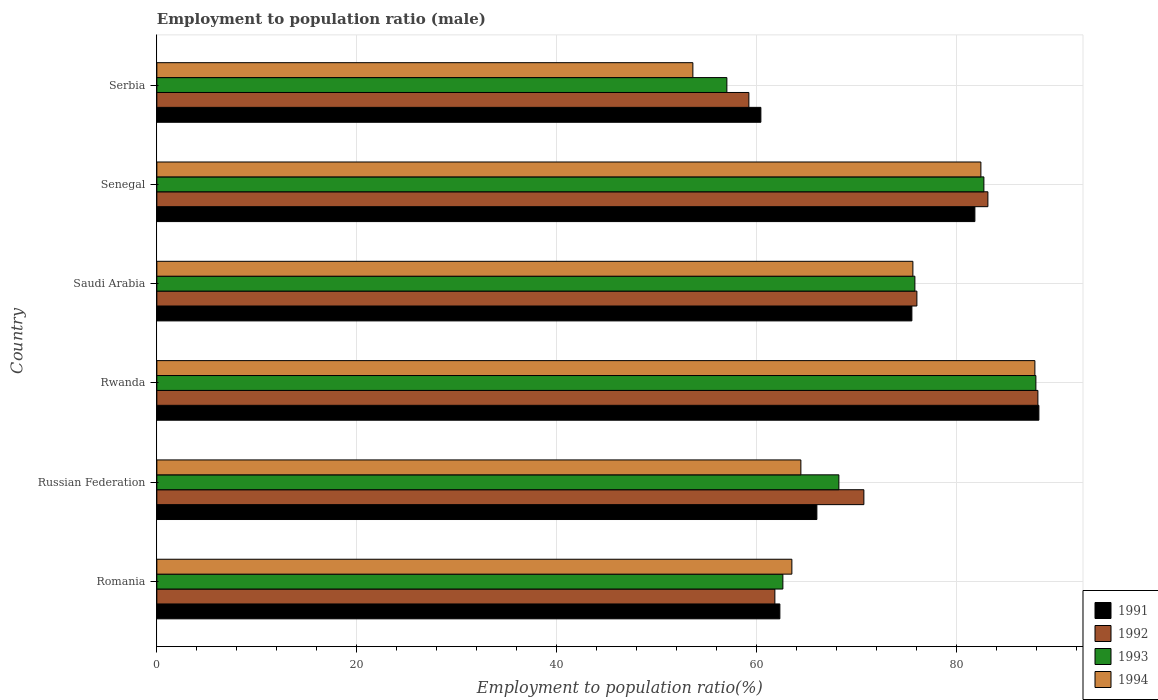How many different coloured bars are there?
Provide a succinct answer. 4. Are the number of bars per tick equal to the number of legend labels?
Keep it short and to the point. Yes. Are the number of bars on each tick of the Y-axis equal?
Offer a very short reply. Yes. How many bars are there on the 5th tick from the top?
Provide a succinct answer. 4. How many bars are there on the 2nd tick from the bottom?
Your answer should be compact. 4. What is the label of the 1st group of bars from the top?
Give a very brief answer. Serbia. In how many cases, is the number of bars for a given country not equal to the number of legend labels?
Your answer should be very brief. 0. What is the employment to population ratio in 1992 in Romania?
Offer a very short reply. 61.8. Across all countries, what is the maximum employment to population ratio in 1994?
Ensure brevity in your answer.  87.8. Across all countries, what is the minimum employment to population ratio in 1991?
Make the answer very short. 60.4. In which country was the employment to population ratio in 1994 maximum?
Your answer should be very brief. Rwanda. In which country was the employment to population ratio in 1991 minimum?
Offer a terse response. Serbia. What is the total employment to population ratio in 1993 in the graph?
Give a very brief answer. 434.2. What is the difference between the employment to population ratio in 1994 in Romania and that in Serbia?
Make the answer very short. 9.9. What is the difference between the employment to population ratio in 1992 in Serbia and the employment to population ratio in 1991 in Russian Federation?
Ensure brevity in your answer.  -6.8. What is the average employment to population ratio in 1993 per country?
Offer a very short reply. 72.37. What is the difference between the employment to population ratio in 1992 and employment to population ratio in 1993 in Rwanda?
Keep it short and to the point. 0.2. In how many countries, is the employment to population ratio in 1992 greater than 56 %?
Keep it short and to the point. 6. What is the ratio of the employment to population ratio in 1994 in Rwanda to that in Serbia?
Offer a terse response. 1.64. Is the employment to population ratio in 1993 in Rwanda less than that in Serbia?
Your answer should be compact. No. What is the difference between the highest and the second highest employment to population ratio in 1994?
Give a very brief answer. 5.4. What is the difference between the highest and the lowest employment to population ratio in 1994?
Provide a succinct answer. 34.2. In how many countries, is the employment to population ratio in 1994 greater than the average employment to population ratio in 1994 taken over all countries?
Your answer should be compact. 3. Is the sum of the employment to population ratio in 1992 in Senegal and Serbia greater than the maximum employment to population ratio in 1994 across all countries?
Your answer should be very brief. Yes. Is it the case that in every country, the sum of the employment to population ratio in 1992 and employment to population ratio in 1993 is greater than the sum of employment to population ratio in 1991 and employment to population ratio in 1994?
Ensure brevity in your answer.  No. What does the 2nd bar from the top in Romania represents?
Offer a terse response. 1993. Are all the bars in the graph horizontal?
Offer a very short reply. Yes. What is the difference between two consecutive major ticks on the X-axis?
Your response must be concise. 20. Are the values on the major ticks of X-axis written in scientific E-notation?
Your answer should be very brief. No. Does the graph contain any zero values?
Your response must be concise. No. How many legend labels are there?
Offer a terse response. 4. How are the legend labels stacked?
Offer a very short reply. Vertical. What is the title of the graph?
Give a very brief answer. Employment to population ratio (male). What is the label or title of the X-axis?
Give a very brief answer. Employment to population ratio(%). What is the label or title of the Y-axis?
Your response must be concise. Country. What is the Employment to population ratio(%) in 1991 in Romania?
Make the answer very short. 62.3. What is the Employment to population ratio(%) of 1992 in Romania?
Your answer should be very brief. 61.8. What is the Employment to population ratio(%) of 1993 in Romania?
Keep it short and to the point. 62.6. What is the Employment to population ratio(%) in 1994 in Romania?
Offer a very short reply. 63.5. What is the Employment to population ratio(%) in 1992 in Russian Federation?
Your answer should be compact. 70.7. What is the Employment to population ratio(%) in 1993 in Russian Federation?
Keep it short and to the point. 68.2. What is the Employment to population ratio(%) of 1994 in Russian Federation?
Keep it short and to the point. 64.4. What is the Employment to population ratio(%) in 1991 in Rwanda?
Your answer should be compact. 88.2. What is the Employment to population ratio(%) of 1992 in Rwanda?
Give a very brief answer. 88.1. What is the Employment to population ratio(%) in 1993 in Rwanda?
Provide a succinct answer. 87.9. What is the Employment to population ratio(%) of 1994 in Rwanda?
Your answer should be compact. 87.8. What is the Employment to population ratio(%) of 1991 in Saudi Arabia?
Make the answer very short. 75.5. What is the Employment to population ratio(%) of 1993 in Saudi Arabia?
Your answer should be very brief. 75.8. What is the Employment to population ratio(%) in 1994 in Saudi Arabia?
Your response must be concise. 75.6. What is the Employment to population ratio(%) in 1991 in Senegal?
Provide a succinct answer. 81.8. What is the Employment to population ratio(%) in 1992 in Senegal?
Make the answer very short. 83.1. What is the Employment to population ratio(%) in 1993 in Senegal?
Ensure brevity in your answer.  82.7. What is the Employment to population ratio(%) of 1994 in Senegal?
Give a very brief answer. 82.4. What is the Employment to population ratio(%) of 1991 in Serbia?
Your response must be concise. 60.4. What is the Employment to population ratio(%) of 1992 in Serbia?
Provide a short and direct response. 59.2. What is the Employment to population ratio(%) of 1993 in Serbia?
Your answer should be compact. 57. What is the Employment to population ratio(%) of 1994 in Serbia?
Your response must be concise. 53.6. Across all countries, what is the maximum Employment to population ratio(%) in 1991?
Your response must be concise. 88.2. Across all countries, what is the maximum Employment to population ratio(%) in 1992?
Offer a very short reply. 88.1. Across all countries, what is the maximum Employment to population ratio(%) of 1993?
Provide a short and direct response. 87.9. Across all countries, what is the maximum Employment to population ratio(%) in 1994?
Keep it short and to the point. 87.8. Across all countries, what is the minimum Employment to population ratio(%) of 1991?
Offer a very short reply. 60.4. Across all countries, what is the minimum Employment to population ratio(%) in 1992?
Your response must be concise. 59.2. Across all countries, what is the minimum Employment to population ratio(%) in 1994?
Offer a terse response. 53.6. What is the total Employment to population ratio(%) of 1991 in the graph?
Make the answer very short. 434.2. What is the total Employment to population ratio(%) of 1992 in the graph?
Your answer should be compact. 438.9. What is the total Employment to population ratio(%) of 1993 in the graph?
Offer a terse response. 434.2. What is the total Employment to population ratio(%) of 1994 in the graph?
Your answer should be very brief. 427.3. What is the difference between the Employment to population ratio(%) in 1992 in Romania and that in Russian Federation?
Offer a very short reply. -8.9. What is the difference between the Employment to population ratio(%) of 1993 in Romania and that in Russian Federation?
Keep it short and to the point. -5.6. What is the difference between the Employment to population ratio(%) of 1994 in Romania and that in Russian Federation?
Provide a succinct answer. -0.9. What is the difference between the Employment to population ratio(%) of 1991 in Romania and that in Rwanda?
Give a very brief answer. -25.9. What is the difference between the Employment to population ratio(%) in 1992 in Romania and that in Rwanda?
Ensure brevity in your answer.  -26.3. What is the difference between the Employment to population ratio(%) of 1993 in Romania and that in Rwanda?
Give a very brief answer. -25.3. What is the difference between the Employment to population ratio(%) in 1994 in Romania and that in Rwanda?
Give a very brief answer. -24.3. What is the difference between the Employment to population ratio(%) in 1991 in Romania and that in Saudi Arabia?
Your answer should be compact. -13.2. What is the difference between the Employment to population ratio(%) in 1993 in Romania and that in Saudi Arabia?
Your answer should be very brief. -13.2. What is the difference between the Employment to population ratio(%) of 1994 in Romania and that in Saudi Arabia?
Keep it short and to the point. -12.1. What is the difference between the Employment to population ratio(%) in 1991 in Romania and that in Senegal?
Your answer should be very brief. -19.5. What is the difference between the Employment to population ratio(%) of 1992 in Romania and that in Senegal?
Provide a short and direct response. -21.3. What is the difference between the Employment to population ratio(%) in 1993 in Romania and that in Senegal?
Offer a very short reply. -20.1. What is the difference between the Employment to population ratio(%) of 1994 in Romania and that in Senegal?
Offer a very short reply. -18.9. What is the difference between the Employment to population ratio(%) of 1993 in Romania and that in Serbia?
Keep it short and to the point. 5.6. What is the difference between the Employment to population ratio(%) in 1994 in Romania and that in Serbia?
Provide a short and direct response. 9.9. What is the difference between the Employment to population ratio(%) in 1991 in Russian Federation and that in Rwanda?
Keep it short and to the point. -22.2. What is the difference between the Employment to population ratio(%) in 1992 in Russian Federation and that in Rwanda?
Your response must be concise. -17.4. What is the difference between the Employment to population ratio(%) in 1993 in Russian Federation and that in Rwanda?
Your answer should be very brief. -19.7. What is the difference between the Employment to population ratio(%) of 1994 in Russian Federation and that in Rwanda?
Keep it short and to the point. -23.4. What is the difference between the Employment to population ratio(%) in 1991 in Russian Federation and that in Saudi Arabia?
Provide a short and direct response. -9.5. What is the difference between the Employment to population ratio(%) in 1992 in Russian Federation and that in Saudi Arabia?
Ensure brevity in your answer.  -5.3. What is the difference between the Employment to population ratio(%) of 1991 in Russian Federation and that in Senegal?
Your answer should be compact. -15.8. What is the difference between the Employment to population ratio(%) of 1994 in Russian Federation and that in Senegal?
Give a very brief answer. -18. What is the difference between the Employment to population ratio(%) of 1992 in Russian Federation and that in Serbia?
Ensure brevity in your answer.  11.5. What is the difference between the Employment to population ratio(%) in 1994 in Russian Federation and that in Serbia?
Keep it short and to the point. 10.8. What is the difference between the Employment to population ratio(%) in 1991 in Rwanda and that in Saudi Arabia?
Offer a terse response. 12.7. What is the difference between the Employment to population ratio(%) in 1992 in Rwanda and that in Saudi Arabia?
Your answer should be compact. 12.1. What is the difference between the Employment to population ratio(%) of 1993 in Rwanda and that in Saudi Arabia?
Keep it short and to the point. 12.1. What is the difference between the Employment to population ratio(%) in 1994 in Rwanda and that in Saudi Arabia?
Make the answer very short. 12.2. What is the difference between the Employment to population ratio(%) of 1992 in Rwanda and that in Senegal?
Your answer should be very brief. 5. What is the difference between the Employment to population ratio(%) of 1993 in Rwanda and that in Senegal?
Give a very brief answer. 5.2. What is the difference between the Employment to population ratio(%) in 1994 in Rwanda and that in Senegal?
Ensure brevity in your answer.  5.4. What is the difference between the Employment to population ratio(%) in 1991 in Rwanda and that in Serbia?
Ensure brevity in your answer.  27.8. What is the difference between the Employment to population ratio(%) in 1992 in Rwanda and that in Serbia?
Give a very brief answer. 28.9. What is the difference between the Employment to population ratio(%) in 1993 in Rwanda and that in Serbia?
Give a very brief answer. 30.9. What is the difference between the Employment to population ratio(%) of 1994 in Rwanda and that in Serbia?
Ensure brevity in your answer.  34.2. What is the difference between the Employment to population ratio(%) of 1992 in Saudi Arabia and that in Senegal?
Offer a terse response. -7.1. What is the difference between the Employment to population ratio(%) in 1992 in Saudi Arabia and that in Serbia?
Offer a terse response. 16.8. What is the difference between the Employment to population ratio(%) of 1993 in Saudi Arabia and that in Serbia?
Make the answer very short. 18.8. What is the difference between the Employment to population ratio(%) in 1991 in Senegal and that in Serbia?
Make the answer very short. 21.4. What is the difference between the Employment to population ratio(%) in 1992 in Senegal and that in Serbia?
Your answer should be compact. 23.9. What is the difference between the Employment to population ratio(%) in 1993 in Senegal and that in Serbia?
Offer a terse response. 25.7. What is the difference between the Employment to population ratio(%) of 1994 in Senegal and that in Serbia?
Provide a succinct answer. 28.8. What is the difference between the Employment to population ratio(%) of 1991 in Romania and the Employment to population ratio(%) of 1992 in Rwanda?
Give a very brief answer. -25.8. What is the difference between the Employment to population ratio(%) of 1991 in Romania and the Employment to population ratio(%) of 1993 in Rwanda?
Your response must be concise. -25.6. What is the difference between the Employment to population ratio(%) of 1991 in Romania and the Employment to population ratio(%) of 1994 in Rwanda?
Ensure brevity in your answer.  -25.5. What is the difference between the Employment to population ratio(%) in 1992 in Romania and the Employment to population ratio(%) in 1993 in Rwanda?
Give a very brief answer. -26.1. What is the difference between the Employment to population ratio(%) in 1992 in Romania and the Employment to population ratio(%) in 1994 in Rwanda?
Give a very brief answer. -26. What is the difference between the Employment to population ratio(%) of 1993 in Romania and the Employment to population ratio(%) of 1994 in Rwanda?
Your answer should be very brief. -25.2. What is the difference between the Employment to population ratio(%) in 1991 in Romania and the Employment to population ratio(%) in 1992 in Saudi Arabia?
Make the answer very short. -13.7. What is the difference between the Employment to population ratio(%) of 1991 in Romania and the Employment to population ratio(%) of 1993 in Saudi Arabia?
Offer a very short reply. -13.5. What is the difference between the Employment to population ratio(%) in 1992 in Romania and the Employment to population ratio(%) in 1994 in Saudi Arabia?
Give a very brief answer. -13.8. What is the difference between the Employment to population ratio(%) in 1991 in Romania and the Employment to population ratio(%) in 1992 in Senegal?
Your response must be concise. -20.8. What is the difference between the Employment to population ratio(%) in 1991 in Romania and the Employment to population ratio(%) in 1993 in Senegal?
Ensure brevity in your answer.  -20.4. What is the difference between the Employment to population ratio(%) of 1991 in Romania and the Employment to population ratio(%) of 1994 in Senegal?
Make the answer very short. -20.1. What is the difference between the Employment to population ratio(%) in 1992 in Romania and the Employment to population ratio(%) in 1993 in Senegal?
Your answer should be compact. -20.9. What is the difference between the Employment to population ratio(%) of 1992 in Romania and the Employment to population ratio(%) of 1994 in Senegal?
Ensure brevity in your answer.  -20.6. What is the difference between the Employment to population ratio(%) of 1993 in Romania and the Employment to population ratio(%) of 1994 in Senegal?
Your response must be concise. -19.8. What is the difference between the Employment to population ratio(%) of 1991 in Romania and the Employment to population ratio(%) of 1993 in Serbia?
Offer a very short reply. 5.3. What is the difference between the Employment to population ratio(%) of 1993 in Romania and the Employment to population ratio(%) of 1994 in Serbia?
Your response must be concise. 9. What is the difference between the Employment to population ratio(%) in 1991 in Russian Federation and the Employment to population ratio(%) in 1992 in Rwanda?
Ensure brevity in your answer.  -22.1. What is the difference between the Employment to population ratio(%) in 1991 in Russian Federation and the Employment to population ratio(%) in 1993 in Rwanda?
Make the answer very short. -21.9. What is the difference between the Employment to population ratio(%) in 1991 in Russian Federation and the Employment to population ratio(%) in 1994 in Rwanda?
Give a very brief answer. -21.8. What is the difference between the Employment to population ratio(%) in 1992 in Russian Federation and the Employment to population ratio(%) in 1993 in Rwanda?
Your answer should be very brief. -17.2. What is the difference between the Employment to population ratio(%) in 1992 in Russian Federation and the Employment to population ratio(%) in 1994 in Rwanda?
Provide a short and direct response. -17.1. What is the difference between the Employment to population ratio(%) in 1993 in Russian Federation and the Employment to population ratio(%) in 1994 in Rwanda?
Your answer should be compact. -19.6. What is the difference between the Employment to population ratio(%) of 1991 in Russian Federation and the Employment to population ratio(%) of 1992 in Saudi Arabia?
Your answer should be very brief. -10. What is the difference between the Employment to population ratio(%) of 1991 in Russian Federation and the Employment to population ratio(%) of 1994 in Saudi Arabia?
Keep it short and to the point. -9.6. What is the difference between the Employment to population ratio(%) in 1992 in Russian Federation and the Employment to population ratio(%) in 1993 in Saudi Arabia?
Your response must be concise. -5.1. What is the difference between the Employment to population ratio(%) of 1992 in Russian Federation and the Employment to population ratio(%) of 1994 in Saudi Arabia?
Your response must be concise. -4.9. What is the difference between the Employment to population ratio(%) of 1991 in Russian Federation and the Employment to population ratio(%) of 1992 in Senegal?
Provide a short and direct response. -17.1. What is the difference between the Employment to population ratio(%) of 1991 in Russian Federation and the Employment to population ratio(%) of 1993 in Senegal?
Keep it short and to the point. -16.7. What is the difference between the Employment to population ratio(%) of 1991 in Russian Federation and the Employment to population ratio(%) of 1994 in Senegal?
Give a very brief answer. -16.4. What is the difference between the Employment to population ratio(%) of 1991 in Russian Federation and the Employment to population ratio(%) of 1994 in Serbia?
Provide a short and direct response. 12.4. What is the difference between the Employment to population ratio(%) of 1992 in Russian Federation and the Employment to population ratio(%) of 1994 in Serbia?
Your answer should be very brief. 17.1. What is the difference between the Employment to population ratio(%) of 1991 in Rwanda and the Employment to population ratio(%) of 1994 in Saudi Arabia?
Provide a short and direct response. 12.6. What is the difference between the Employment to population ratio(%) of 1992 in Rwanda and the Employment to population ratio(%) of 1993 in Saudi Arabia?
Provide a short and direct response. 12.3. What is the difference between the Employment to population ratio(%) in 1992 in Rwanda and the Employment to population ratio(%) in 1994 in Saudi Arabia?
Provide a succinct answer. 12.5. What is the difference between the Employment to population ratio(%) in 1991 in Rwanda and the Employment to population ratio(%) in 1993 in Senegal?
Provide a succinct answer. 5.5. What is the difference between the Employment to population ratio(%) of 1991 in Rwanda and the Employment to population ratio(%) of 1994 in Senegal?
Give a very brief answer. 5.8. What is the difference between the Employment to population ratio(%) in 1992 in Rwanda and the Employment to population ratio(%) in 1993 in Senegal?
Keep it short and to the point. 5.4. What is the difference between the Employment to population ratio(%) of 1992 in Rwanda and the Employment to population ratio(%) of 1994 in Senegal?
Your response must be concise. 5.7. What is the difference between the Employment to population ratio(%) in 1991 in Rwanda and the Employment to population ratio(%) in 1992 in Serbia?
Keep it short and to the point. 29. What is the difference between the Employment to population ratio(%) in 1991 in Rwanda and the Employment to population ratio(%) in 1993 in Serbia?
Your response must be concise. 31.2. What is the difference between the Employment to population ratio(%) of 1991 in Rwanda and the Employment to population ratio(%) of 1994 in Serbia?
Ensure brevity in your answer.  34.6. What is the difference between the Employment to population ratio(%) in 1992 in Rwanda and the Employment to population ratio(%) in 1993 in Serbia?
Give a very brief answer. 31.1. What is the difference between the Employment to population ratio(%) in 1992 in Rwanda and the Employment to population ratio(%) in 1994 in Serbia?
Make the answer very short. 34.5. What is the difference between the Employment to population ratio(%) of 1993 in Rwanda and the Employment to population ratio(%) of 1994 in Serbia?
Make the answer very short. 34.3. What is the difference between the Employment to population ratio(%) of 1991 in Saudi Arabia and the Employment to population ratio(%) of 1993 in Senegal?
Provide a short and direct response. -7.2. What is the difference between the Employment to population ratio(%) of 1991 in Saudi Arabia and the Employment to population ratio(%) of 1994 in Senegal?
Offer a terse response. -6.9. What is the difference between the Employment to population ratio(%) in 1992 in Saudi Arabia and the Employment to population ratio(%) in 1993 in Senegal?
Keep it short and to the point. -6.7. What is the difference between the Employment to population ratio(%) of 1992 in Saudi Arabia and the Employment to population ratio(%) of 1994 in Senegal?
Ensure brevity in your answer.  -6.4. What is the difference between the Employment to population ratio(%) of 1993 in Saudi Arabia and the Employment to population ratio(%) of 1994 in Senegal?
Keep it short and to the point. -6.6. What is the difference between the Employment to population ratio(%) in 1991 in Saudi Arabia and the Employment to population ratio(%) in 1992 in Serbia?
Give a very brief answer. 16.3. What is the difference between the Employment to population ratio(%) in 1991 in Saudi Arabia and the Employment to population ratio(%) in 1993 in Serbia?
Keep it short and to the point. 18.5. What is the difference between the Employment to population ratio(%) in 1991 in Saudi Arabia and the Employment to population ratio(%) in 1994 in Serbia?
Ensure brevity in your answer.  21.9. What is the difference between the Employment to population ratio(%) of 1992 in Saudi Arabia and the Employment to population ratio(%) of 1994 in Serbia?
Make the answer very short. 22.4. What is the difference between the Employment to population ratio(%) in 1993 in Saudi Arabia and the Employment to population ratio(%) in 1994 in Serbia?
Offer a terse response. 22.2. What is the difference between the Employment to population ratio(%) in 1991 in Senegal and the Employment to population ratio(%) in 1992 in Serbia?
Your answer should be compact. 22.6. What is the difference between the Employment to population ratio(%) in 1991 in Senegal and the Employment to population ratio(%) in 1993 in Serbia?
Keep it short and to the point. 24.8. What is the difference between the Employment to population ratio(%) in 1991 in Senegal and the Employment to population ratio(%) in 1994 in Serbia?
Your response must be concise. 28.2. What is the difference between the Employment to population ratio(%) of 1992 in Senegal and the Employment to population ratio(%) of 1993 in Serbia?
Make the answer very short. 26.1. What is the difference between the Employment to population ratio(%) of 1992 in Senegal and the Employment to population ratio(%) of 1994 in Serbia?
Your answer should be very brief. 29.5. What is the difference between the Employment to population ratio(%) of 1993 in Senegal and the Employment to population ratio(%) of 1994 in Serbia?
Offer a very short reply. 29.1. What is the average Employment to population ratio(%) in 1991 per country?
Offer a very short reply. 72.37. What is the average Employment to population ratio(%) in 1992 per country?
Provide a succinct answer. 73.15. What is the average Employment to population ratio(%) in 1993 per country?
Make the answer very short. 72.37. What is the average Employment to population ratio(%) of 1994 per country?
Provide a short and direct response. 71.22. What is the difference between the Employment to population ratio(%) in 1991 and Employment to population ratio(%) in 1993 in Romania?
Give a very brief answer. -0.3. What is the difference between the Employment to population ratio(%) in 1992 and Employment to population ratio(%) in 1994 in Romania?
Your response must be concise. -1.7. What is the difference between the Employment to population ratio(%) in 1991 and Employment to population ratio(%) in 1992 in Russian Federation?
Offer a very short reply. -4.7. What is the difference between the Employment to population ratio(%) of 1991 and Employment to population ratio(%) of 1993 in Russian Federation?
Your answer should be compact. -2.2. What is the difference between the Employment to population ratio(%) of 1991 and Employment to population ratio(%) of 1994 in Russian Federation?
Offer a very short reply. 1.6. What is the difference between the Employment to population ratio(%) of 1991 and Employment to population ratio(%) of 1993 in Rwanda?
Make the answer very short. 0.3. What is the difference between the Employment to population ratio(%) in 1992 and Employment to population ratio(%) in 1993 in Rwanda?
Make the answer very short. 0.2. What is the difference between the Employment to population ratio(%) in 1993 and Employment to population ratio(%) in 1994 in Rwanda?
Provide a succinct answer. 0.1. What is the difference between the Employment to population ratio(%) of 1991 and Employment to population ratio(%) of 1994 in Saudi Arabia?
Give a very brief answer. -0.1. What is the difference between the Employment to population ratio(%) of 1992 and Employment to population ratio(%) of 1993 in Saudi Arabia?
Offer a very short reply. 0.2. What is the difference between the Employment to population ratio(%) in 1992 and Employment to population ratio(%) in 1994 in Saudi Arabia?
Make the answer very short. 0.4. What is the difference between the Employment to population ratio(%) of 1991 and Employment to population ratio(%) of 1992 in Senegal?
Keep it short and to the point. -1.3. What is the difference between the Employment to population ratio(%) in 1993 and Employment to population ratio(%) in 1994 in Senegal?
Offer a terse response. 0.3. What is the difference between the Employment to population ratio(%) in 1991 and Employment to population ratio(%) in 1992 in Serbia?
Your response must be concise. 1.2. What is the difference between the Employment to population ratio(%) of 1991 and Employment to population ratio(%) of 1993 in Serbia?
Offer a very short reply. 3.4. What is the difference between the Employment to population ratio(%) of 1991 and Employment to population ratio(%) of 1994 in Serbia?
Offer a terse response. 6.8. What is the difference between the Employment to population ratio(%) in 1992 and Employment to population ratio(%) in 1994 in Serbia?
Your answer should be very brief. 5.6. What is the difference between the Employment to population ratio(%) in 1993 and Employment to population ratio(%) in 1994 in Serbia?
Your answer should be very brief. 3.4. What is the ratio of the Employment to population ratio(%) in 1991 in Romania to that in Russian Federation?
Keep it short and to the point. 0.94. What is the ratio of the Employment to population ratio(%) in 1992 in Romania to that in Russian Federation?
Ensure brevity in your answer.  0.87. What is the ratio of the Employment to population ratio(%) of 1993 in Romania to that in Russian Federation?
Your answer should be very brief. 0.92. What is the ratio of the Employment to population ratio(%) in 1994 in Romania to that in Russian Federation?
Offer a very short reply. 0.99. What is the ratio of the Employment to population ratio(%) of 1991 in Romania to that in Rwanda?
Provide a short and direct response. 0.71. What is the ratio of the Employment to population ratio(%) in 1992 in Romania to that in Rwanda?
Your response must be concise. 0.7. What is the ratio of the Employment to population ratio(%) in 1993 in Romania to that in Rwanda?
Give a very brief answer. 0.71. What is the ratio of the Employment to population ratio(%) of 1994 in Romania to that in Rwanda?
Offer a very short reply. 0.72. What is the ratio of the Employment to population ratio(%) of 1991 in Romania to that in Saudi Arabia?
Provide a succinct answer. 0.83. What is the ratio of the Employment to population ratio(%) in 1992 in Romania to that in Saudi Arabia?
Offer a terse response. 0.81. What is the ratio of the Employment to population ratio(%) in 1993 in Romania to that in Saudi Arabia?
Provide a short and direct response. 0.83. What is the ratio of the Employment to population ratio(%) in 1994 in Romania to that in Saudi Arabia?
Give a very brief answer. 0.84. What is the ratio of the Employment to population ratio(%) in 1991 in Romania to that in Senegal?
Offer a terse response. 0.76. What is the ratio of the Employment to population ratio(%) in 1992 in Romania to that in Senegal?
Make the answer very short. 0.74. What is the ratio of the Employment to population ratio(%) of 1993 in Romania to that in Senegal?
Provide a short and direct response. 0.76. What is the ratio of the Employment to population ratio(%) of 1994 in Romania to that in Senegal?
Provide a succinct answer. 0.77. What is the ratio of the Employment to population ratio(%) in 1991 in Romania to that in Serbia?
Provide a short and direct response. 1.03. What is the ratio of the Employment to population ratio(%) in 1992 in Romania to that in Serbia?
Ensure brevity in your answer.  1.04. What is the ratio of the Employment to population ratio(%) of 1993 in Romania to that in Serbia?
Provide a short and direct response. 1.1. What is the ratio of the Employment to population ratio(%) in 1994 in Romania to that in Serbia?
Your answer should be very brief. 1.18. What is the ratio of the Employment to population ratio(%) of 1991 in Russian Federation to that in Rwanda?
Your answer should be very brief. 0.75. What is the ratio of the Employment to population ratio(%) of 1992 in Russian Federation to that in Rwanda?
Your answer should be very brief. 0.8. What is the ratio of the Employment to population ratio(%) in 1993 in Russian Federation to that in Rwanda?
Give a very brief answer. 0.78. What is the ratio of the Employment to population ratio(%) of 1994 in Russian Federation to that in Rwanda?
Your answer should be very brief. 0.73. What is the ratio of the Employment to population ratio(%) of 1991 in Russian Federation to that in Saudi Arabia?
Offer a very short reply. 0.87. What is the ratio of the Employment to population ratio(%) in 1992 in Russian Federation to that in Saudi Arabia?
Provide a succinct answer. 0.93. What is the ratio of the Employment to population ratio(%) of 1993 in Russian Federation to that in Saudi Arabia?
Your answer should be very brief. 0.9. What is the ratio of the Employment to population ratio(%) of 1994 in Russian Federation to that in Saudi Arabia?
Your answer should be compact. 0.85. What is the ratio of the Employment to population ratio(%) in 1991 in Russian Federation to that in Senegal?
Your answer should be compact. 0.81. What is the ratio of the Employment to population ratio(%) of 1992 in Russian Federation to that in Senegal?
Your response must be concise. 0.85. What is the ratio of the Employment to population ratio(%) in 1993 in Russian Federation to that in Senegal?
Provide a short and direct response. 0.82. What is the ratio of the Employment to population ratio(%) in 1994 in Russian Federation to that in Senegal?
Keep it short and to the point. 0.78. What is the ratio of the Employment to population ratio(%) in 1991 in Russian Federation to that in Serbia?
Your response must be concise. 1.09. What is the ratio of the Employment to population ratio(%) of 1992 in Russian Federation to that in Serbia?
Make the answer very short. 1.19. What is the ratio of the Employment to population ratio(%) in 1993 in Russian Federation to that in Serbia?
Your answer should be compact. 1.2. What is the ratio of the Employment to population ratio(%) of 1994 in Russian Federation to that in Serbia?
Provide a short and direct response. 1.2. What is the ratio of the Employment to population ratio(%) in 1991 in Rwanda to that in Saudi Arabia?
Keep it short and to the point. 1.17. What is the ratio of the Employment to population ratio(%) in 1992 in Rwanda to that in Saudi Arabia?
Make the answer very short. 1.16. What is the ratio of the Employment to population ratio(%) in 1993 in Rwanda to that in Saudi Arabia?
Offer a terse response. 1.16. What is the ratio of the Employment to population ratio(%) in 1994 in Rwanda to that in Saudi Arabia?
Give a very brief answer. 1.16. What is the ratio of the Employment to population ratio(%) of 1991 in Rwanda to that in Senegal?
Provide a succinct answer. 1.08. What is the ratio of the Employment to population ratio(%) of 1992 in Rwanda to that in Senegal?
Your answer should be compact. 1.06. What is the ratio of the Employment to population ratio(%) of 1993 in Rwanda to that in Senegal?
Give a very brief answer. 1.06. What is the ratio of the Employment to population ratio(%) in 1994 in Rwanda to that in Senegal?
Offer a terse response. 1.07. What is the ratio of the Employment to population ratio(%) of 1991 in Rwanda to that in Serbia?
Offer a terse response. 1.46. What is the ratio of the Employment to population ratio(%) of 1992 in Rwanda to that in Serbia?
Give a very brief answer. 1.49. What is the ratio of the Employment to population ratio(%) in 1993 in Rwanda to that in Serbia?
Provide a succinct answer. 1.54. What is the ratio of the Employment to population ratio(%) in 1994 in Rwanda to that in Serbia?
Your answer should be very brief. 1.64. What is the ratio of the Employment to population ratio(%) in 1991 in Saudi Arabia to that in Senegal?
Give a very brief answer. 0.92. What is the ratio of the Employment to population ratio(%) in 1992 in Saudi Arabia to that in Senegal?
Provide a short and direct response. 0.91. What is the ratio of the Employment to population ratio(%) in 1993 in Saudi Arabia to that in Senegal?
Make the answer very short. 0.92. What is the ratio of the Employment to population ratio(%) in 1994 in Saudi Arabia to that in Senegal?
Your answer should be very brief. 0.92. What is the ratio of the Employment to population ratio(%) of 1991 in Saudi Arabia to that in Serbia?
Offer a terse response. 1.25. What is the ratio of the Employment to population ratio(%) of 1992 in Saudi Arabia to that in Serbia?
Ensure brevity in your answer.  1.28. What is the ratio of the Employment to population ratio(%) of 1993 in Saudi Arabia to that in Serbia?
Your response must be concise. 1.33. What is the ratio of the Employment to population ratio(%) in 1994 in Saudi Arabia to that in Serbia?
Give a very brief answer. 1.41. What is the ratio of the Employment to population ratio(%) of 1991 in Senegal to that in Serbia?
Your answer should be compact. 1.35. What is the ratio of the Employment to population ratio(%) of 1992 in Senegal to that in Serbia?
Offer a terse response. 1.4. What is the ratio of the Employment to population ratio(%) in 1993 in Senegal to that in Serbia?
Make the answer very short. 1.45. What is the ratio of the Employment to population ratio(%) of 1994 in Senegal to that in Serbia?
Your answer should be very brief. 1.54. What is the difference between the highest and the second highest Employment to population ratio(%) in 1991?
Offer a terse response. 6.4. What is the difference between the highest and the second highest Employment to population ratio(%) in 1992?
Your answer should be very brief. 5. What is the difference between the highest and the lowest Employment to population ratio(%) in 1991?
Make the answer very short. 27.8. What is the difference between the highest and the lowest Employment to population ratio(%) of 1992?
Your response must be concise. 28.9. What is the difference between the highest and the lowest Employment to population ratio(%) in 1993?
Offer a very short reply. 30.9. What is the difference between the highest and the lowest Employment to population ratio(%) in 1994?
Offer a terse response. 34.2. 